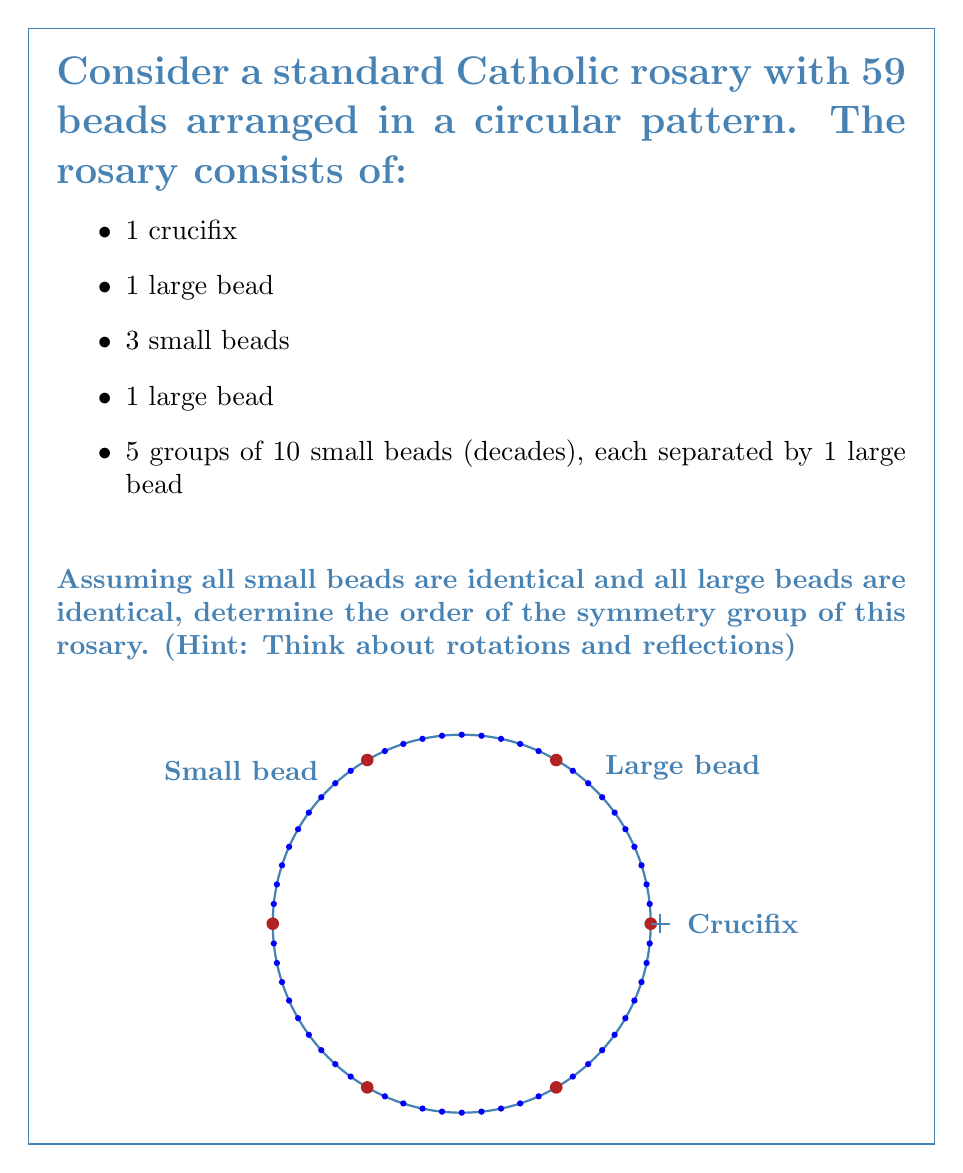What is the answer to this math problem? Let's approach this step-by-step:

1) First, we need to identify the symmetries of the rosary:

   a) Rotational symmetry: The rosary can be rotated by multiples of $\frac{2\pi}{5}$ (72°) and still look the same. This is because there are 5 decades, each separated by a large bead.

   b) Reflection symmetry: The rosary can be reflected across 5 different axes (through each of the 5 large beads separating the decades).

2) Now, let's count these symmetries:

   a) Rotations: There are 5 possible rotations (including the identity rotation):
      $$0°, 72°, 144°, 216°, 288°$$

   b) Reflections: There are 5 possible reflections.

3) The total number of symmetries is the sum of rotations and reflections:
   $$5 \text{ rotations} + 5 \text{ reflections} = 10 \text{ symmetries}$$

4) In group theory, the number of elements in a group is called the order of the group. Therefore, the order of the symmetry group of this rosary is 10.

5) This symmetry group is actually isomorphic to the dihedral group $D_5$, which is the group of symmetries of a regular pentagon.
Answer: 10 